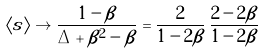Convert formula to latex. <formula><loc_0><loc_0><loc_500><loc_500>\langle s \rangle \to \frac { 1 - \beta } { \Delta + \beta ^ { 2 } - \beta } = \frac { 2 } { 1 - 2 \beta } \, \frac { 2 - 2 \beta } { 1 - 2 \beta }</formula> 